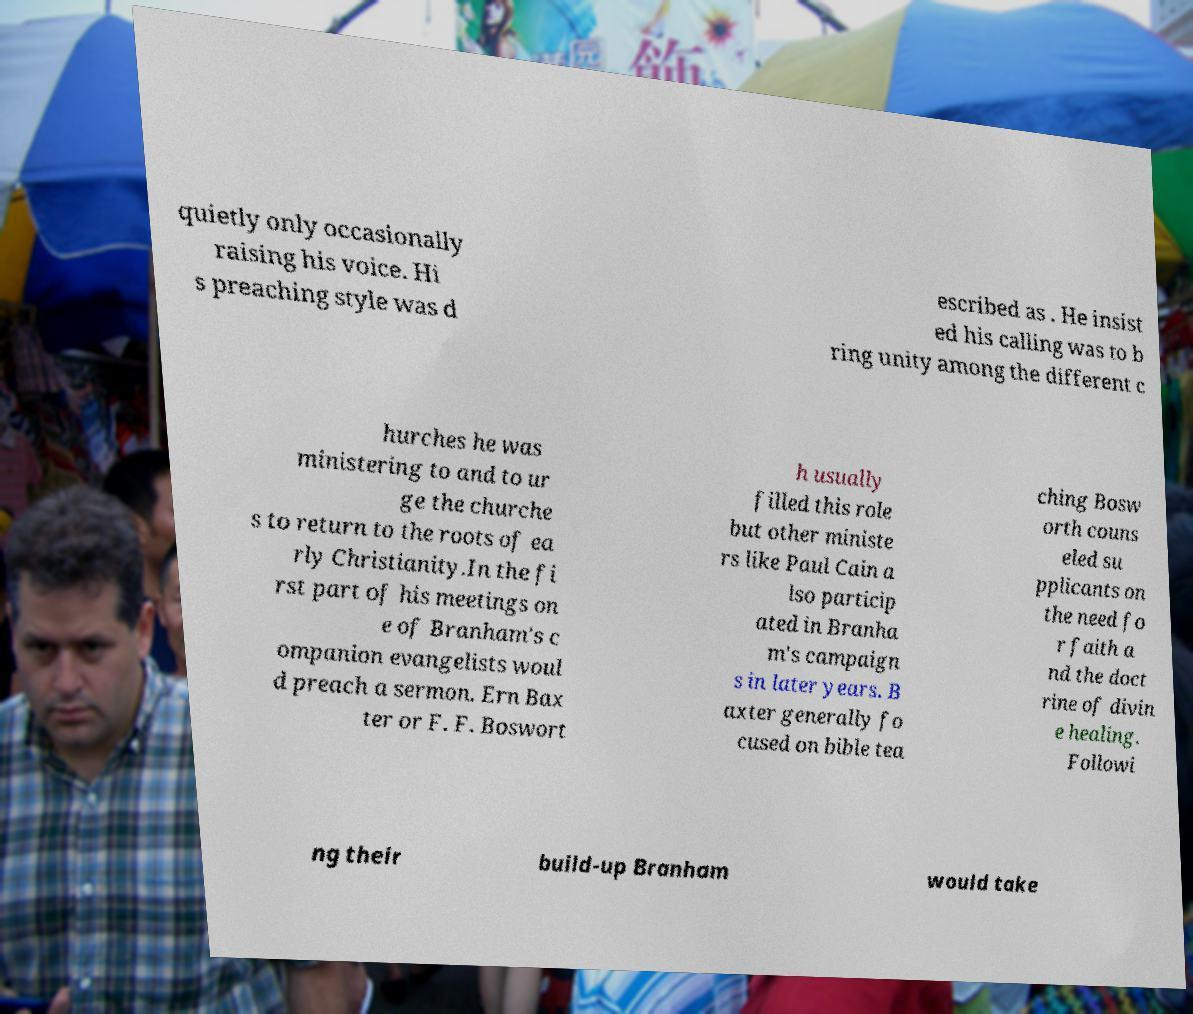Can you read and provide the text displayed in the image?This photo seems to have some interesting text. Can you extract and type it out for me? quietly only occasionally raising his voice. Hi s preaching style was d escribed as . He insist ed his calling was to b ring unity among the different c hurches he was ministering to and to ur ge the churche s to return to the roots of ea rly Christianity.In the fi rst part of his meetings on e of Branham's c ompanion evangelists woul d preach a sermon. Ern Bax ter or F. F. Boswort h usually filled this role but other ministe rs like Paul Cain a lso particip ated in Branha m's campaign s in later years. B axter generally fo cused on bible tea ching Bosw orth couns eled su pplicants on the need fo r faith a nd the doct rine of divin e healing. Followi ng their build-up Branham would take 